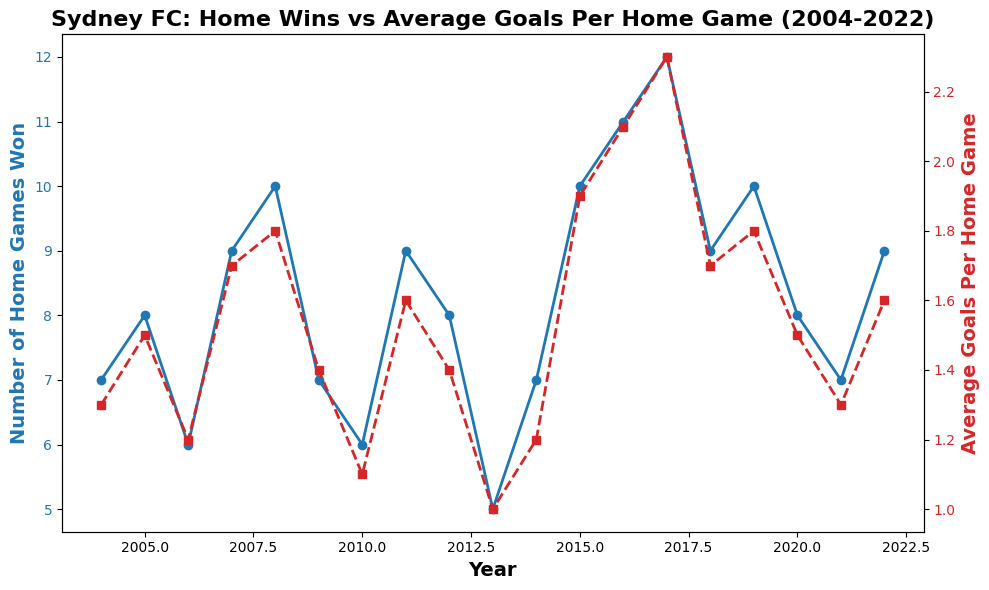What's the highest number of home games won for Sydney FC in the given period? Look for the peak of the blue line representing "Number of Home Games Won" on the primary y-axis. Identify the year with the highest value.
Answer: 2017 Which year had the lowest average goals per home game? Check the red line representing "Average Goals Per Home Game" on the secondary y-axis. Identify the year with the minimum value.
Answer: 2013 In which year did Sydney FC win 10 home games and what was the average number of goals scored per home game in that year? Find the year where the blue line hits 10 on the primary y-axis. Then, match it with the corresponding value on the red line for that year.
Answer: 2008 and 2019; 1.8 Compare the number of home games won in 2004 and 2022. Which year had more, and by how many games? Check the blue lines for the years 2004 and 2022. Subtract the value for 2004 from the value for 2022 to find the difference.
Answer: 2022 had 2 more home games won What was the average number of goals per home game in the year when Sydney FC won the most home games? Identify the year with the highest value on the blue line. Then, refer to the corresponding value on the red line for that year.
Answer: 2.3 How many total home games did Sydney FC win from 2010 to 2012 inclusive? Sum the values on the blue line for the years 2010, 2011, and 2012.
Answer: 23 During which year did Sydney FC win exactly 9 home games, and what was the average number of goals scored per home game in that year? Locate the year(s) where the blue line indicates 9 home games won. Check the red line for the average goals for each corresponding year.
Answer: 2007, 2011, 2018, 2022; 1.7, 1.6, 1.7, 1.6 Is there a year where the average goals per home game and the number of home games won were both above their respective medians? First find the median values of "Number of Home Games Won" and "Average Goals Per Home Game". Check each year above these medians for both metrics.
Answer: 2019 Which year had the most significant increase in the number of home games won compared to the previous year, and what was the change in the average goals per home game? Identify the largest positive difference between consecutive values on the blue line. Note the change in values on the red line for these years.
Answer: 2017, with an increase in average goals from 1.9 to 2.3 What is the trend between 2015 to 2017 regarding the number of home games won and the average goals per home game? Observe the slopes of the blue and red lines between 2015 and 2017. Look for increasing, decreasing, or stable patterns.
Answer: Both increased 